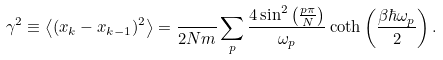Convert formula to latex. <formula><loc_0><loc_0><loc_500><loc_500>\gamma ^ { 2 } \equiv \left < ( x _ { k } - x _ { k - 1 } ) ^ { 2 } \right > = \frac { } { 2 N m } \sum _ { p } \frac { 4 \sin ^ { 2 } \left ( \frac { p \pi } { N } \right ) } { \omega _ { p } } \coth \left ( \frac { \beta \hbar { \omega } _ { p } } { 2 } \right ) .</formula> 